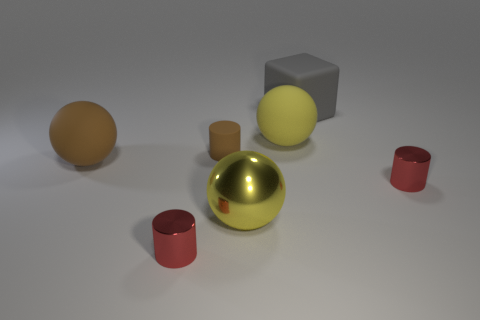Add 2 big yellow shiny balls. How many objects exist? 9 Subtract all blocks. How many objects are left? 6 Subtract all yellow metal things. Subtract all big rubber blocks. How many objects are left? 5 Add 2 tiny rubber things. How many tiny rubber things are left? 3 Add 2 big objects. How many big objects exist? 6 Subtract 0 yellow cylinders. How many objects are left? 7 